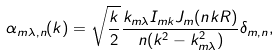<formula> <loc_0><loc_0><loc_500><loc_500>\alpha _ { m \lambda , n } ( k ) = \sqrt { \frac { k } { 2 } } \frac { k _ { m \lambda } I _ { m k } J _ { m } ( n k R ) } { n ( k ^ { 2 } - k _ { m \lambda } ^ { 2 } ) } \delta _ { m , n } ,</formula> 